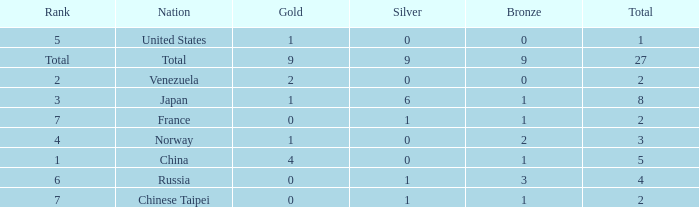What is the sum of Bronze when the total is more than 27? None. 